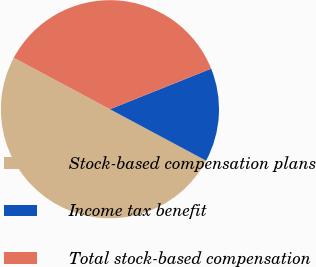Convert chart to OTSL. <chart><loc_0><loc_0><loc_500><loc_500><pie_chart><fcel>Stock-based compensation plans<fcel>Income tax benefit<fcel>Total stock-based compensation<nl><fcel>50.0%<fcel>13.89%<fcel>36.11%<nl></chart> 